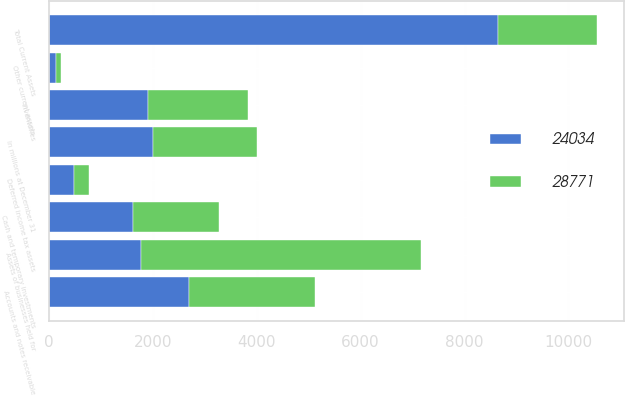Convert chart to OTSL. <chart><loc_0><loc_0><loc_500><loc_500><stacked_bar_chart><ecel><fcel>In millions at December 31<fcel>Cash and temporary investments<fcel>Accounts and notes receivable<fcel>Inventories<fcel>Assets of businesses held for<fcel>Deferred income tax assets<fcel>Other current assets<fcel>Total Current Assets<nl><fcel>24034<fcel>2006<fcel>1624<fcel>2704<fcel>1909<fcel>1778<fcel>490<fcel>132<fcel>8637<nl><fcel>28771<fcel>2005<fcel>1641<fcel>2416<fcel>1932<fcel>5382<fcel>278<fcel>110<fcel>1909<nl></chart> 